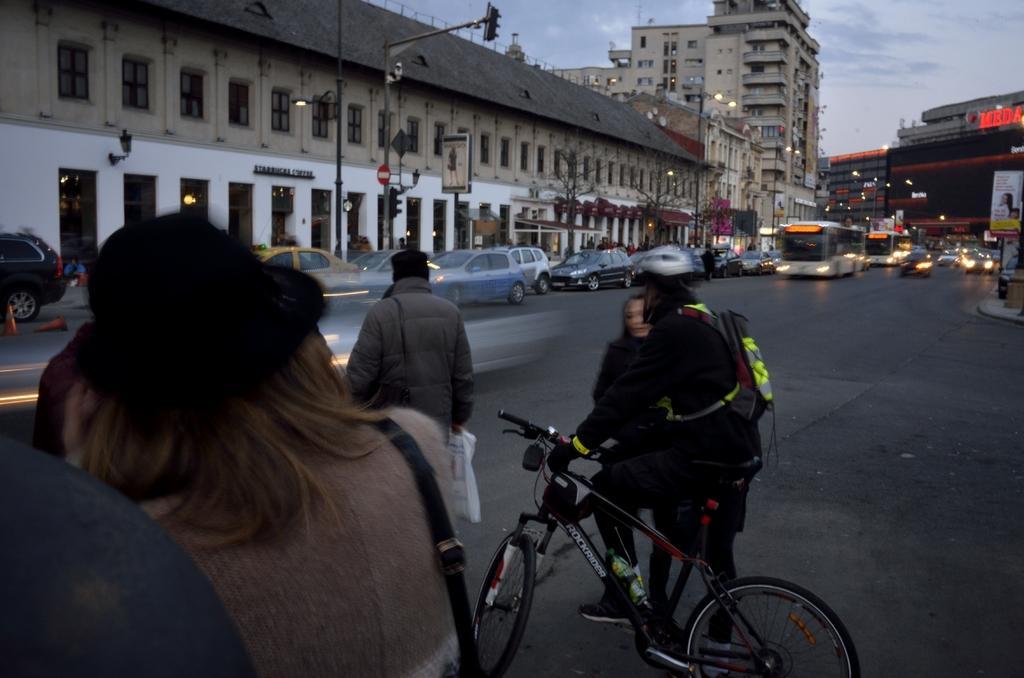Describe this image in one or two sentences. In this image I can see a person riding a bicycle. On the road there are vehicles and few peoples standing. At the back side we can see a building. 